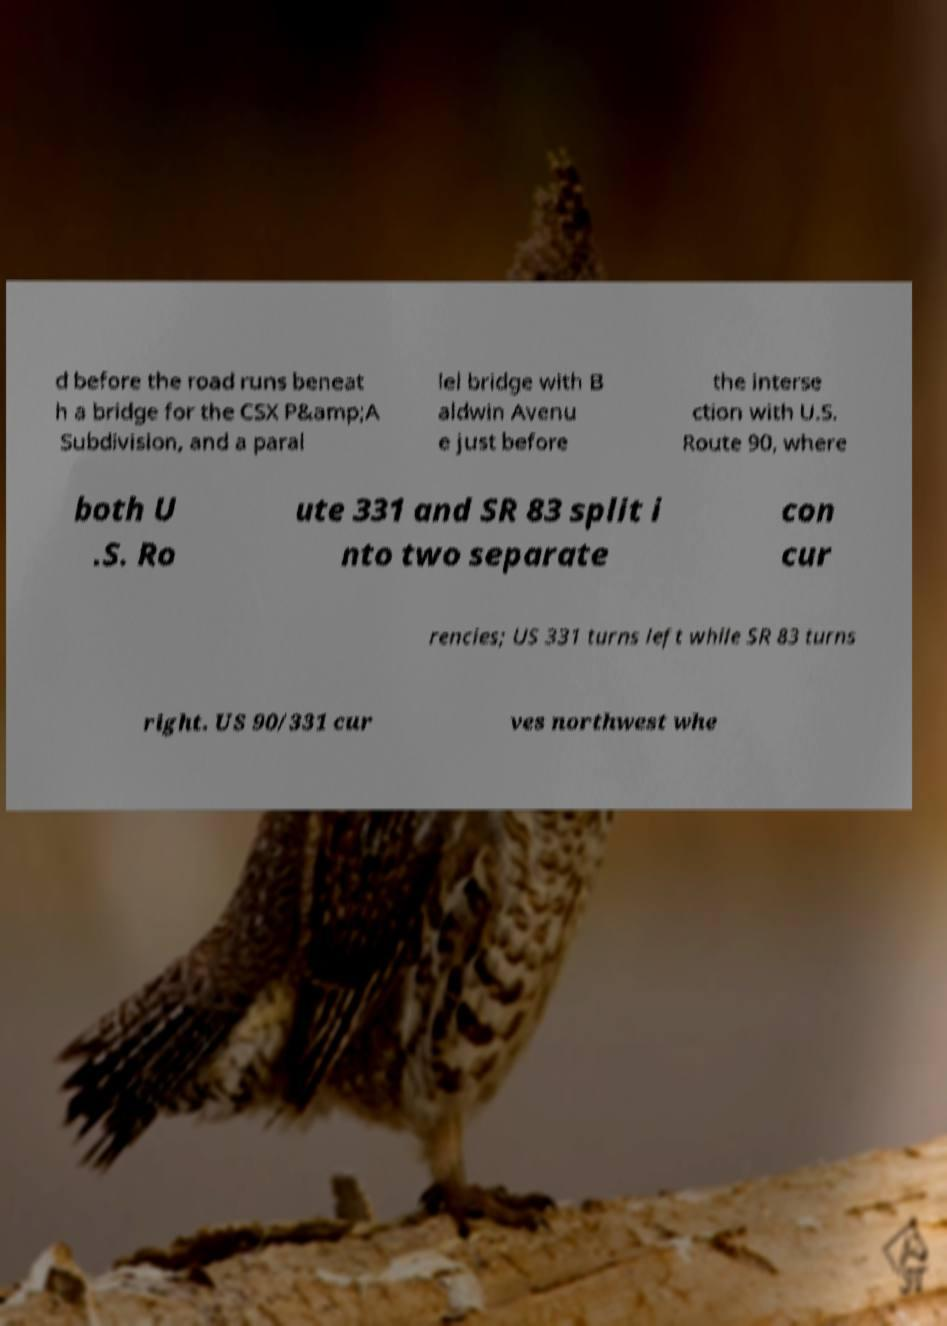Can you read and provide the text displayed in the image?This photo seems to have some interesting text. Can you extract and type it out for me? d before the road runs beneat h a bridge for the CSX P&amp;A Subdivision, and a paral lel bridge with B aldwin Avenu e just before the interse ction with U.S. Route 90, where both U .S. Ro ute 331 and SR 83 split i nto two separate con cur rencies; US 331 turns left while SR 83 turns right. US 90/331 cur ves northwest whe 